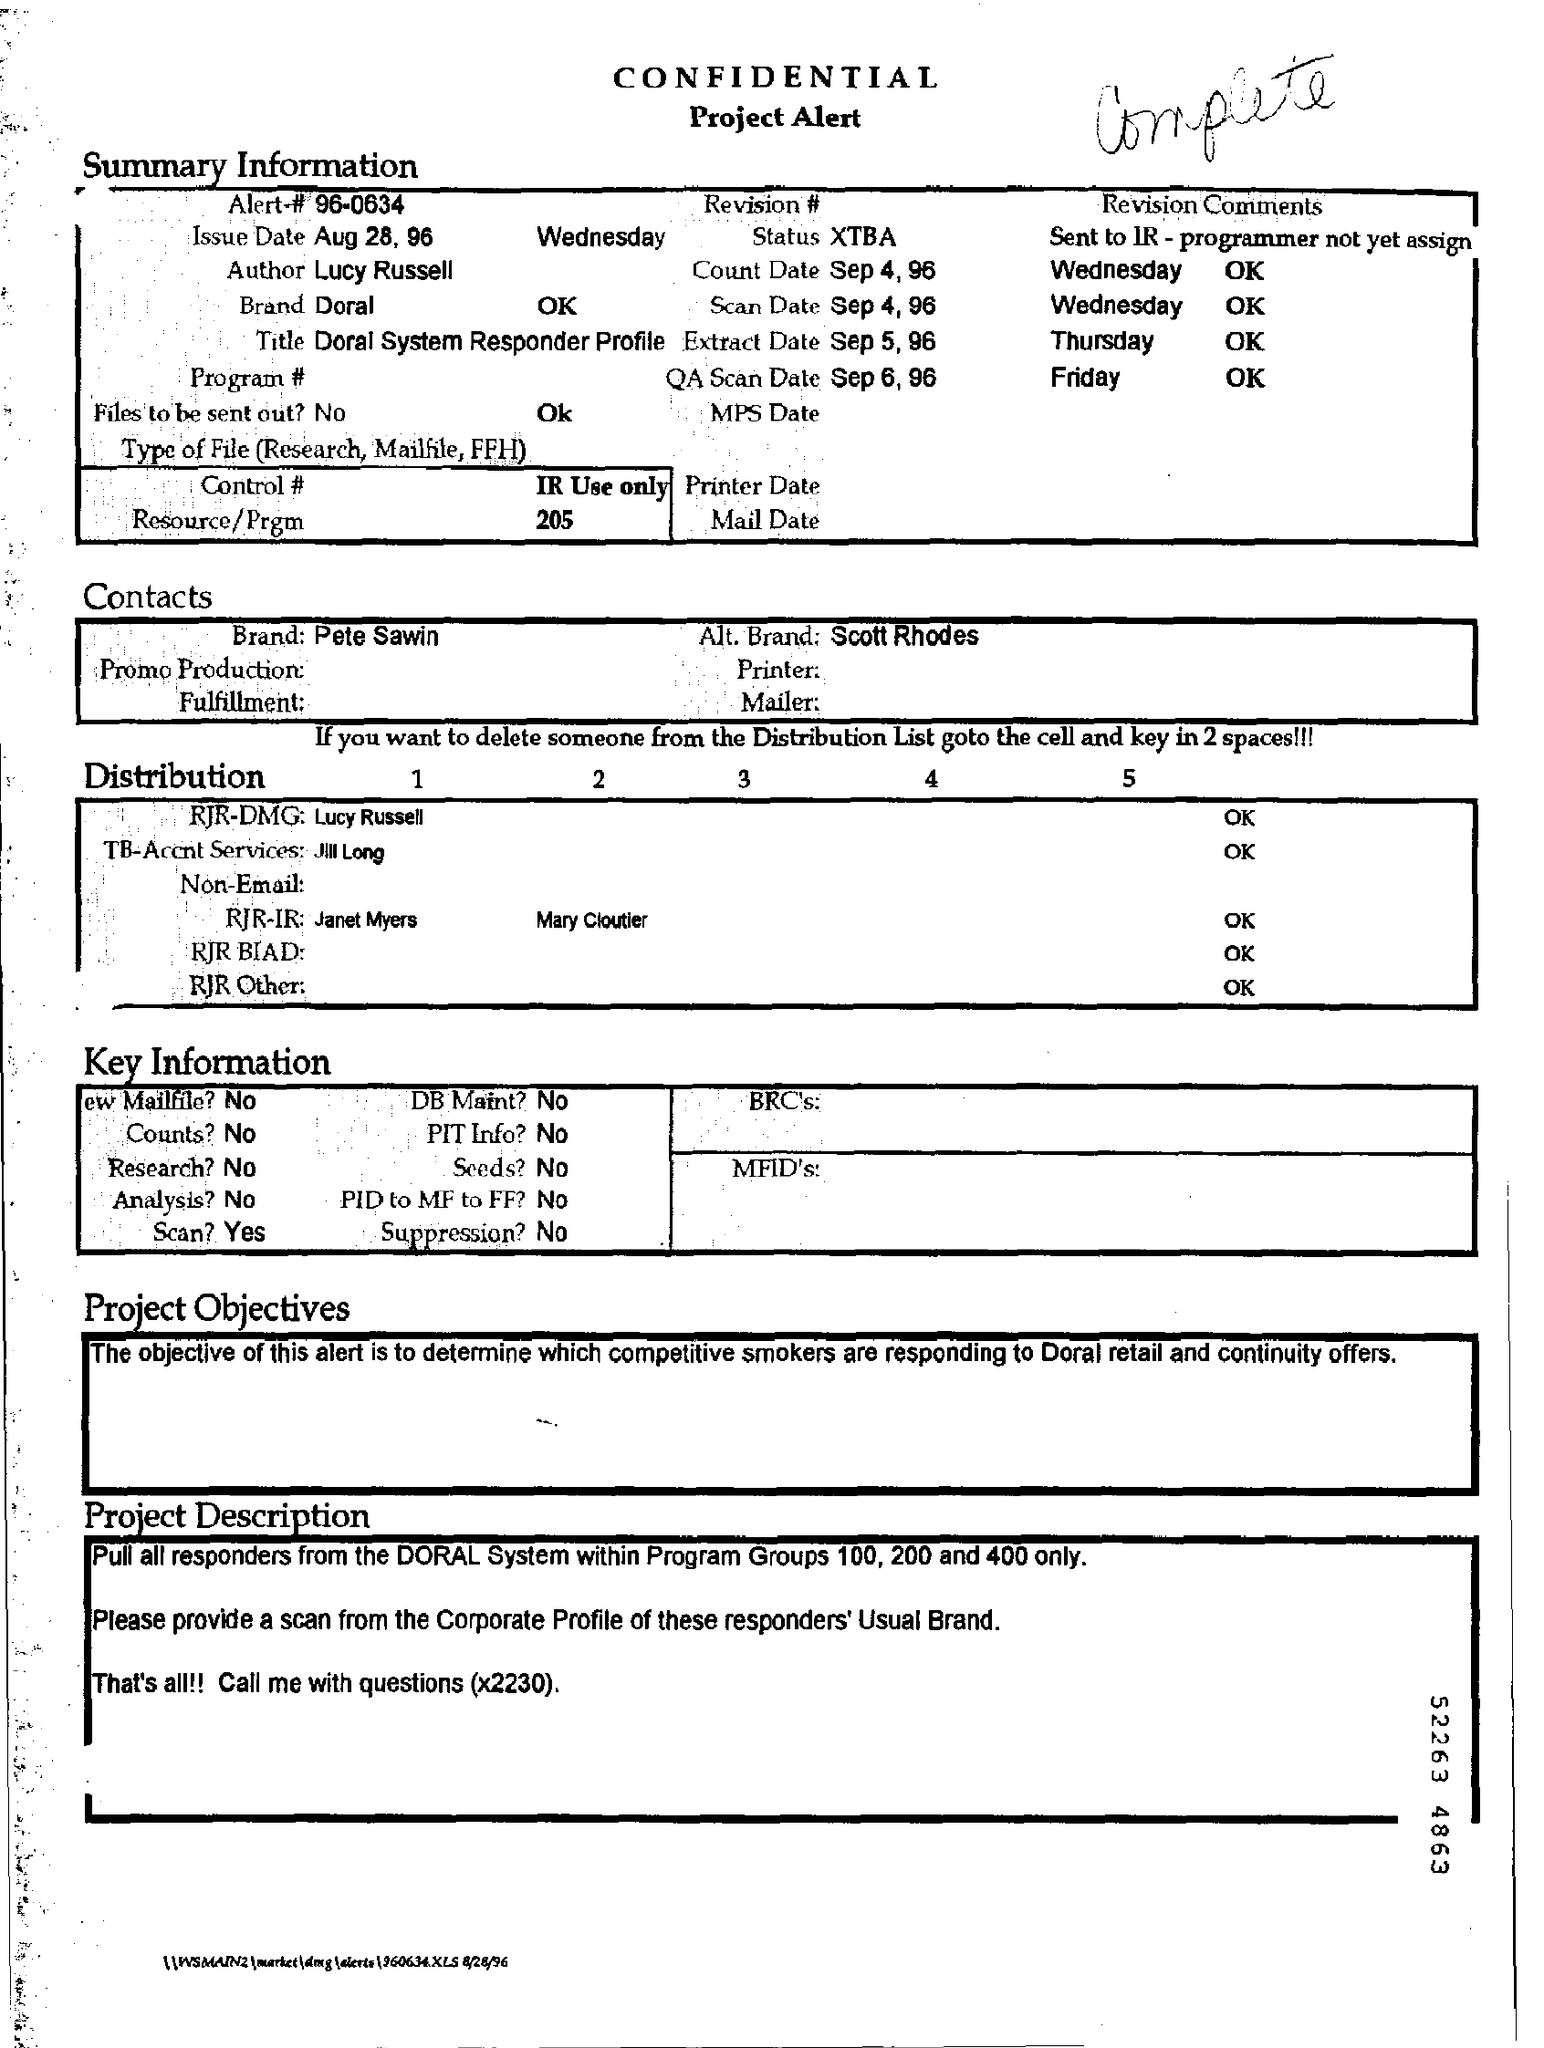Identify some key points in this picture. The text that is written by hand at the top of the page is complete. What is Alert#? 96-0634 is a question asking for information about Alert#, a possible code or identifier. 